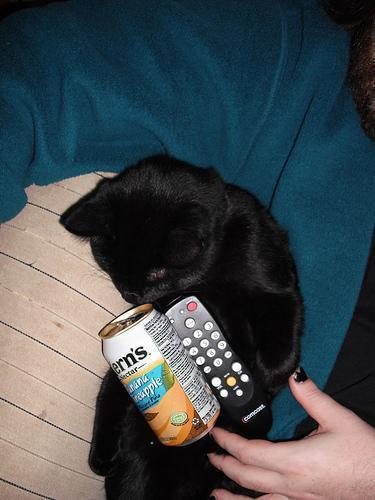How many bananas are in the photo?
Give a very brief answer. 0. 